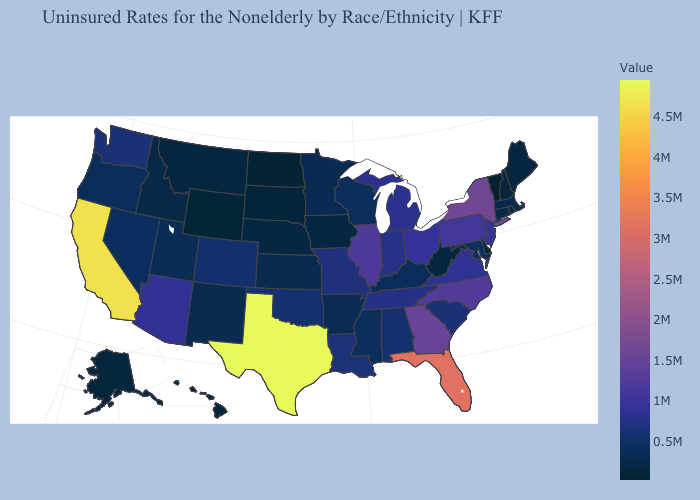Which states have the lowest value in the USA?
Be succinct. Vermont. Among the states that border Georgia , which have the highest value?
Keep it brief. Florida. Does Massachusetts have the lowest value in the USA?
Be succinct. No. Which states have the lowest value in the West?
Keep it brief. Hawaii. Among the states that border Tennessee , does Georgia have the highest value?
Short answer required. Yes. 